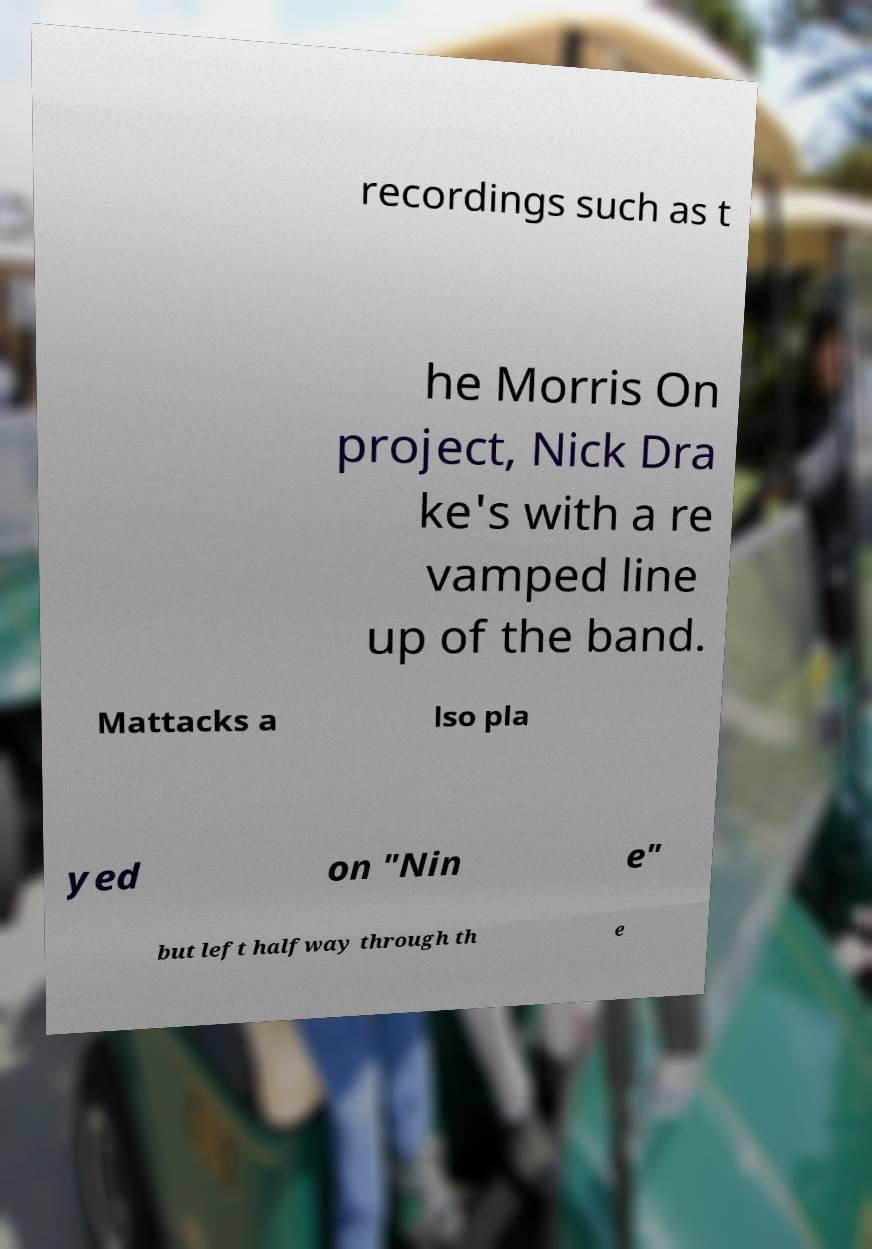Please identify and transcribe the text found in this image. recordings such as t he Morris On project, Nick Dra ke's with a re vamped line up of the band. Mattacks a lso pla yed on "Nin e" but left halfway through th e 